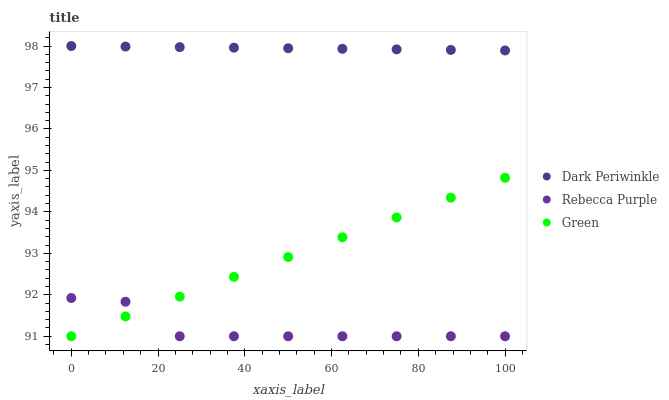Does Rebecca Purple have the minimum area under the curve?
Answer yes or no. Yes. Does Dark Periwinkle have the maximum area under the curve?
Answer yes or no. Yes. Does Dark Periwinkle have the minimum area under the curve?
Answer yes or no. No. Does Rebecca Purple have the maximum area under the curve?
Answer yes or no. No. Is Dark Periwinkle the smoothest?
Answer yes or no. Yes. Is Rebecca Purple the roughest?
Answer yes or no. Yes. Is Rebecca Purple the smoothest?
Answer yes or no. No. Is Dark Periwinkle the roughest?
Answer yes or no. No. Does Green have the lowest value?
Answer yes or no. Yes. Does Dark Periwinkle have the lowest value?
Answer yes or no. No. Does Dark Periwinkle have the highest value?
Answer yes or no. Yes. Does Rebecca Purple have the highest value?
Answer yes or no. No. Is Rebecca Purple less than Dark Periwinkle?
Answer yes or no. Yes. Is Dark Periwinkle greater than Rebecca Purple?
Answer yes or no. Yes. Does Rebecca Purple intersect Green?
Answer yes or no. Yes. Is Rebecca Purple less than Green?
Answer yes or no. No. Is Rebecca Purple greater than Green?
Answer yes or no. No. Does Rebecca Purple intersect Dark Periwinkle?
Answer yes or no. No. 